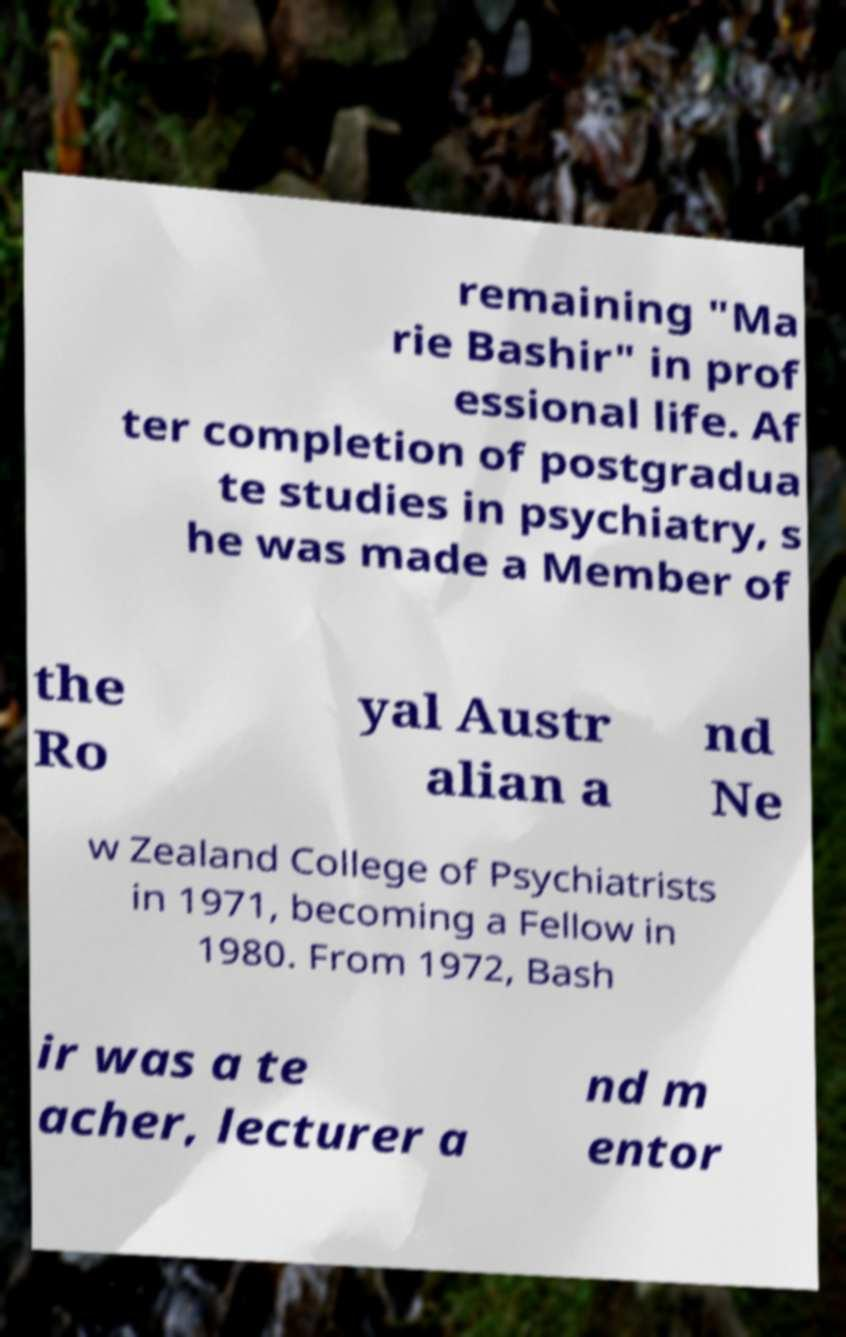Please identify and transcribe the text found in this image. remaining "Ma rie Bashir" in prof essional life. Af ter completion of postgradua te studies in psychiatry, s he was made a Member of the Ro yal Austr alian a nd Ne w Zealand College of Psychiatrists in 1971, becoming a Fellow in 1980. From 1972, Bash ir was a te acher, lecturer a nd m entor 